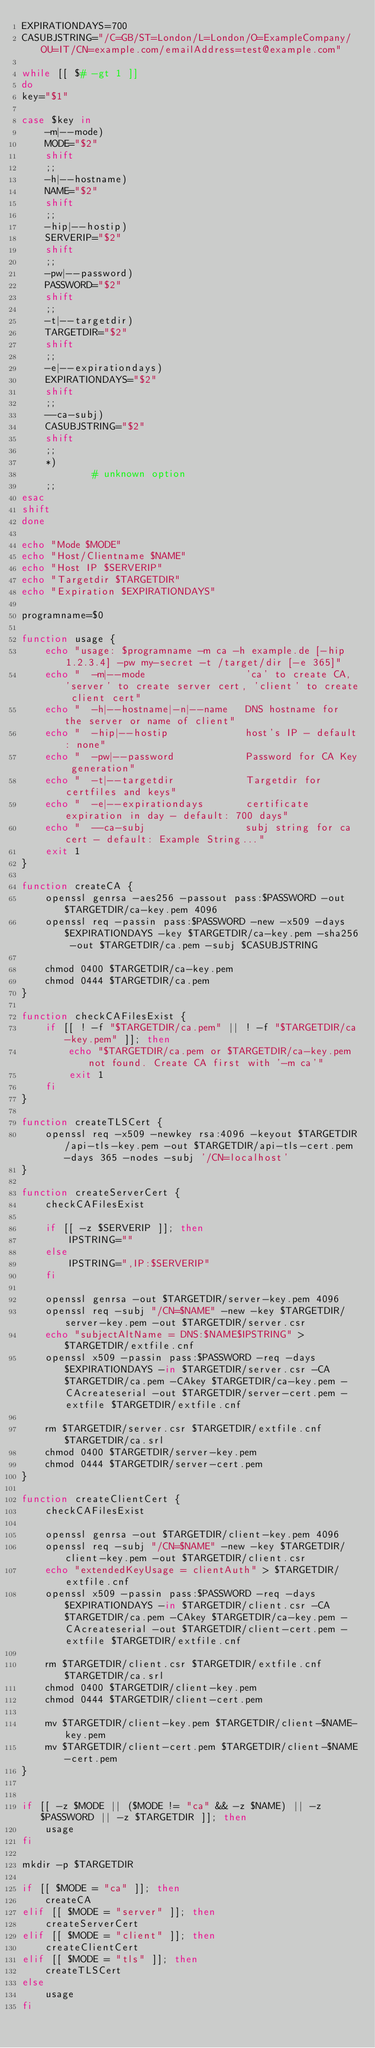<code> <loc_0><loc_0><loc_500><loc_500><_Bash_>EXPIRATIONDAYS=700
CASUBJSTRING="/C=GB/ST=London/L=London/O=ExampleCompany/OU=IT/CN=example.com/emailAddress=test@example.com"

while [[ $# -gt 1 ]]
do
key="$1"

case $key in
    -m|--mode)
    MODE="$2"
    shift
    ;;
    -h|--hostname)
    NAME="$2"
    shift
    ;;
    -hip|--hostip)
    SERVERIP="$2"
    shift
    ;;
    -pw|--password)
    PASSWORD="$2"
    shift
    ;;
    -t|--targetdir)
    TARGETDIR="$2"
    shift
    ;;
    -e|--expirationdays)
    EXPIRATIONDAYS="$2"
    shift
    ;;
    --ca-subj)
    CASUBJSTRING="$2"
    shift
    ;;
    *)
            # unknown option
    ;;
esac
shift
done

echo "Mode $MODE"
echo "Host/Clientname $NAME"
echo "Host IP $SERVERIP"
echo "Targetdir $TARGETDIR"
echo "Expiration $EXPIRATIONDAYS"

programname=$0

function usage {
    echo "usage: $programname -m ca -h example.de [-hip 1.2.3.4] -pw my-secret -t /target/dir [-e 365]"
    echo "  -m|--mode                 'ca' to create CA, 'server' to create server cert, 'client' to create client cert"
    echo "  -h|--hostname|-n|--name   DNS hostname for the server or name of client"
    echo "  -hip|--hostip             host's IP - default: none"
    echo "  -pw|--password            Password for CA Key generation"
    echo "  -t|--targetdir            Targetdir for certfiles and keys"
    echo "  -e|--expirationdays       certificate expiration in day - default: 700 days"
    echo "  --ca-subj                 subj string for ca cert - default: Example String..."
    exit 1
}

function createCA {
    openssl genrsa -aes256 -passout pass:$PASSWORD -out $TARGETDIR/ca-key.pem 4096
    openssl req -passin pass:$PASSWORD -new -x509 -days $EXPIRATIONDAYS -key $TARGETDIR/ca-key.pem -sha256 -out $TARGETDIR/ca.pem -subj $CASUBJSTRING

    chmod 0400 $TARGETDIR/ca-key.pem
    chmod 0444 $TARGETDIR/ca.pem
}

function checkCAFilesExist {
    if [[ ! -f "$TARGETDIR/ca.pem" || ! -f "$TARGETDIR/ca-key.pem" ]]; then
        echo "$TARGETDIR/ca.pem or $TARGETDIR/ca-key.pem not found. Create CA first with '-m ca'"
        exit 1
    fi
}

function createTLSCert {
    openssl req -x509 -newkey rsa:4096 -keyout $TARGETDIR/api-tls-key.pem -out $TARGETDIR/api-tls-cert.pem -days 365 -nodes -subj '/CN=localhost'
}

function createServerCert {
    checkCAFilesExist

    if [[ -z $SERVERIP ]]; then
        IPSTRING=""
    else
        IPSTRING=",IP:$SERVERIP"
    fi

    openssl genrsa -out $TARGETDIR/server-key.pem 4096
    openssl req -subj "/CN=$NAME" -new -key $TARGETDIR/server-key.pem -out $TARGETDIR/server.csr
    echo "subjectAltName = DNS:$NAME$IPSTRING" > $TARGETDIR/extfile.cnf
    openssl x509 -passin pass:$PASSWORD -req -days $EXPIRATIONDAYS -in $TARGETDIR/server.csr -CA $TARGETDIR/ca.pem -CAkey $TARGETDIR/ca-key.pem -CAcreateserial -out $TARGETDIR/server-cert.pem -extfile $TARGETDIR/extfile.cnf

    rm $TARGETDIR/server.csr $TARGETDIR/extfile.cnf $TARGETDIR/ca.srl
    chmod 0400 $TARGETDIR/server-key.pem
    chmod 0444 $TARGETDIR/server-cert.pem
}

function createClientCert {
    checkCAFilesExist

    openssl genrsa -out $TARGETDIR/client-key.pem 4096
    openssl req -subj "/CN=$NAME" -new -key $TARGETDIR/client-key.pem -out $TARGETDIR/client.csr
    echo "extendedKeyUsage = clientAuth" > $TARGETDIR/extfile.cnf
    openssl x509 -passin pass:$PASSWORD -req -days $EXPIRATIONDAYS -in $TARGETDIR/client.csr -CA $TARGETDIR/ca.pem -CAkey $TARGETDIR/ca-key.pem -CAcreateserial -out $TARGETDIR/client-cert.pem -extfile $TARGETDIR/extfile.cnf

    rm $TARGETDIR/client.csr $TARGETDIR/extfile.cnf $TARGETDIR/ca.srl
    chmod 0400 $TARGETDIR/client-key.pem
    chmod 0444 $TARGETDIR/client-cert.pem

    mv $TARGETDIR/client-key.pem $TARGETDIR/client-$NAME-key.pem
    mv $TARGETDIR/client-cert.pem $TARGETDIR/client-$NAME-cert.pem
}


if [[ -z $MODE || ($MODE != "ca" && -z $NAME) || -z $PASSWORD || -z $TARGETDIR ]]; then
    usage
fi

mkdir -p $TARGETDIR

if [[ $MODE = "ca" ]]; then
    createCA
elif [[ $MODE = "server" ]]; then
    createServerCert
elif [[ $MODE = "client" ]]; then
    createClientCert
elif [[ $MODE = "tls" ]]; then
    createTLSCert
else
    usage
fi
</code> 